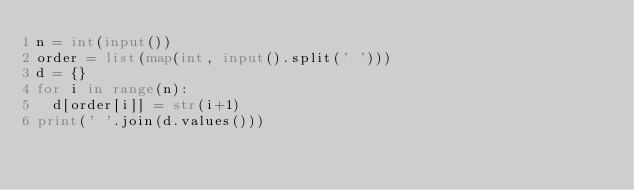Convert code to text. <code><loc_0><loc_0><loc_500><loc_500><_Python_>n = int(input())
order = list(map(int, input().split(' ')))
d = {}
for i in range(n):
  d[order[i]] = str(i+1)
print(' '.join(d.values()))
</code> 